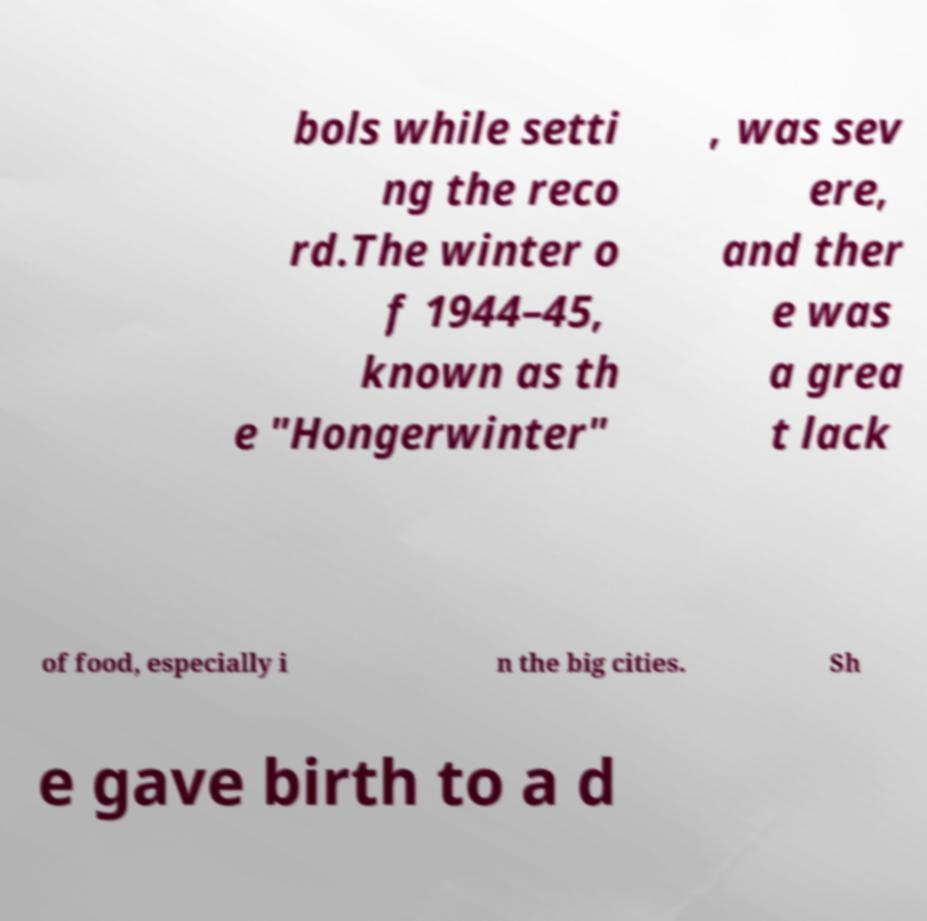Please identify and transcribe the text found in this image. bols while setti ng the reco rd.The winter o f 1944–45, known as th e "Hongerwinter" , was sev ere, and ther e was a grea t lack of food, especially i n the big cities. Sh e gave birth to a d 